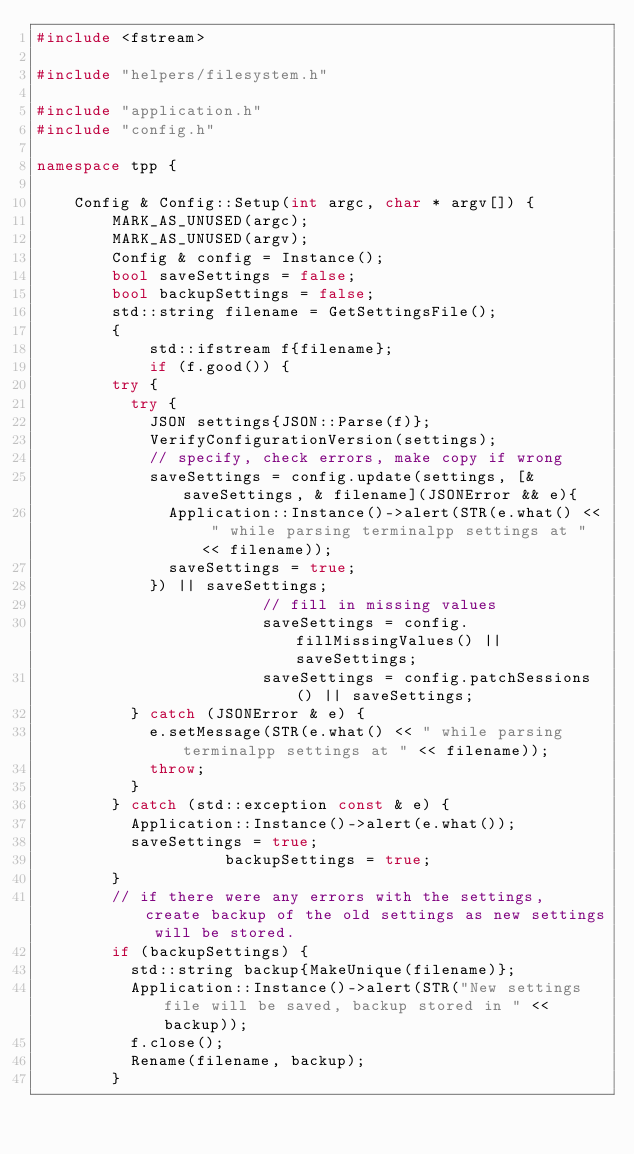<code> <loc_0><loc_0><loc_500><loc_500><_C++_>#include <fstream>

#include "helpers/filesystem.h"

#include "application.h"
#include "config.h"

namespace tpp { 

    Config & Config::Setup(int argc, char * argv[]) {
        MARK_AS_UNUSED(argc);
        MARK_AS_UNUSED(argv);
        Config & config = Instance();
        bool saveSettings = false;
        bool backupSettings = false;
        std::string filename = GetSettingsFile();
        {
            std::ifstream f{filename};
            if (f.good()) {
				try {
					try {
						JSON settings{JSON::Parse(f)};
						VerifyConfigurationVersion(settings);
						// specify, check errors, make copy if wrong
						saveSettings = config.update(settings, [& saveSettings, & filename](JSONError && e){
							Application::Instance()->alert(STR(e.what() << " while parsing terminalpp settings at " << filename));
							saveSettings = true;
						}) || saveSettings;
                        // fill in missing values
                        saveSettings = config.fillMissingValues() || saveSettings;
                        saveSettings = config.patchSessions() || saveSettings;
					} catch (JSONError & e) {
						e.setMessage(STR(e.what() << " while parsing terminalpp settings at " << filename));
						throw;
					}
				} catch (std::exception const & e) {
					Application::Instance()->alert(e.what());
					saveSettings = true;
                    backupSettings = true;
				}
				// if there were any errors with the settings, create backup of the old settings as new settings will be stored. 
				if (backupSettings) {
					std::string backup{MakeUnique(filename)};
					Application::Instance()->alert(STR("New settings file will be saved, backup stored in " << backup));
					f.close();
					Rename(filename, backup);
				}</code> 